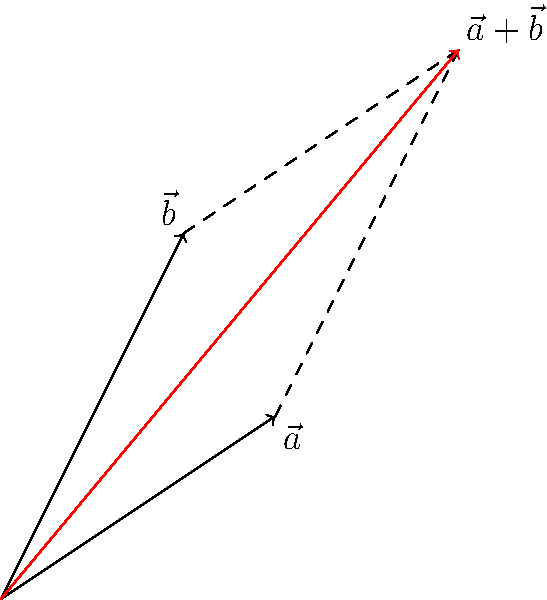In the context of vector addition, consider two vectors $\vec{a}$ and $\vec{b}$ represented by arrows in a two-dimensional plane. Vector $\vec{a}$ extends from the origin to point (3,2), while vector $\vec{b}$ extends from the origin to point (2,4). What are the coordinates of the resultant vector $\vec{r} = \vec{a} + \vec{b}$? To find the resultant vector when adding two vectors, we can use the following steps:

1. Identify the components of each vector:
   $\vec{a} = (3,2)$
   $\vec{b} = (2,4)$

2. Add the corresponding components of the two vectors:
   $\vec{r}_x = a_x + b_x = 3 + 2 = 5$
   $\vec{r}_y = a_y + b_y = 2 + 4 = 6$

3. Express the resultant vector as an ordered pair:
   $\vec{r} = \vec{a} + \vec{b} = (5,6)$

This method is equivalent to the parallelogram rule of vector addition, where we construct a parallelogram using the two vectors and find the diagonal from the origin to the opposite corner. The red arrow in the diagram represents this resultant vector.

The magnitude and direction of the resultant vector can be calculated using the Pythagorean theorem and inverse tangent function, respectively, if needed. However, for this question, we are only concerned with the coordinates of the resultant vector.
Answer: $(5,6)$ 